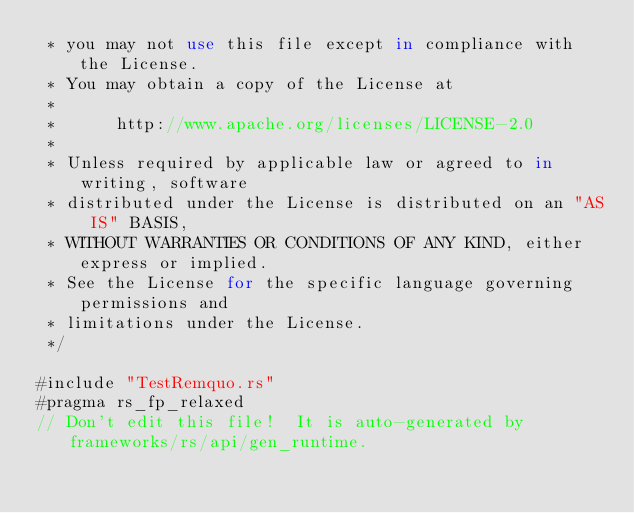Convert code to text. <code><loc_0><loc_0><loc_500><loc_500><_Rust_> * you may not use this file except in compliance with the License.
 * You may obtain a copy of the License at
 *
 *      http://www.apache.org/licenses/LICENSE-2.0
 *
 * Unless required by applicable law or agreed to in writing, software
 * distributed under the License is distributed on an "AS IS" BASIS,
 * WITHOUT WARRANTIES OR CONDITIONS OF ANY KIND, either express or implied.
 * See the License for the specific language governing permissions and
 * limitations under the License.
 */

#include "TestRemquo.rs"
#pragma rs_fp_relaxed
// Don't edit this file!  It is auto-generated by frameworks/rs/api/gen_runtime.

</code> 